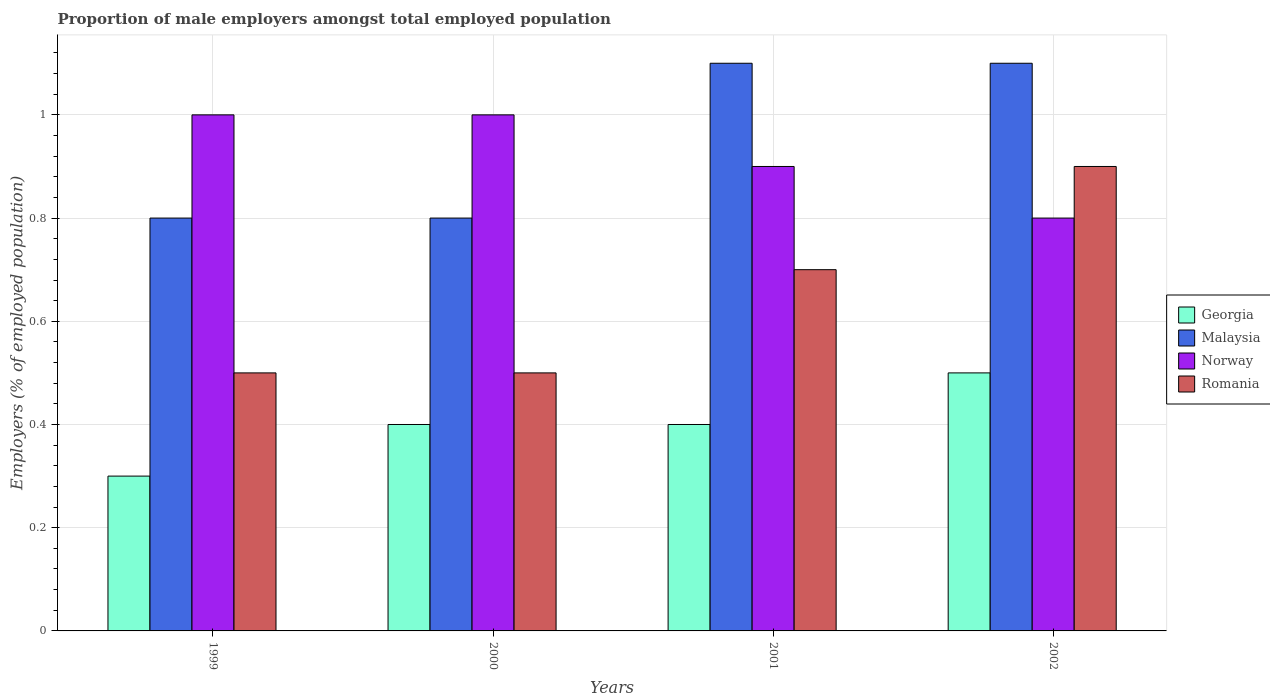How many different coloured bars are there?
Keep it short and to the point. 4. How many groups of bars are there?
Your response must be concise. 4. How many bars are there on the 3rd tick from the left?
Your answer should be very brief. 4. What is the proportion of male employers in Romania in 2001?
Offer a very short reply. 0.7. Across all years, what is the maximum proportion of male employers in Norway?
Offer a terse response. 1. Across all years, what is the minimum proportion of male employers in Malaysia?
Offer a very short reply. 0.8. In which year was the proportion of male employers in Malaysia minimum?
Offer a very short reply. 1999. What is the total proportion of male employers in Malaysia in the graph?
Offer a very short reply. 3.8. What is the difference between the proportion of male employers in Norway in 1999 and that in 2002?
Your answer should be very brief. 0.2. What is the difference between the proportion of male employers in Romania in 2002 and the proportion of male employers in Georgia in 1999?
Your response must be concise. 0.6. What is the average proportion of male employers in Norway per year?
Your answer should be compact. 0.92. In the year 2001, what is the difference between the proportion of male employers in Romania and proportion of male employers in Georgia?
Provide a succinct answer. 0.3. What is the ratio of the proportion of male employers in Georgia in 2000 to that in 2002?
Offer a terse response. 0.8. Is the proportion of male employers in Norway in 2001 less than that in 2002?
Ensure brevity in your answer.  No. What is the difference between the highest and the lowest proportion of male employers in Georgia?
Provide a short and direct response. 0.2. Is the sum of the proportion of male employers in Romania in 1999 and 2001 greater than the maximum proportion of male employers in Georgia across all years?
Your answer should be very brief. Yes. Is it the case that in every year, the sum of the proportion of male employers in Norway and proportion of male employers in Malaysia is greater than the sum of proportion of male employers in Georgia and proportion of male employers in Romania?
Your response must be concise. Yes. What does the 1st bar from the left in 2002 represents?
Offer a terse response. Georgia. What does the 2nd bar from the right in 2001 represents?
Your answer should be very brief. Norway. How many bars are there?
Provide a short and direct response. 16. How many years are there in the graph?
Offer a terse response. 4. What is the difference between two consecutive major ticks on the Y-axis?
Your answer should be very brief. 0.2. Does the graph contain any zero values?
Provide a short and direct response. No. Does the graph contain grids?
Your answer should be compact. Yes. How are the legend labels stacked?
Provide a succinct answer. Vertical. What is the title of the graph?
Give a very brief answer. Proportion of male employers amongst total employed population. What is the label or title of the Y-axis?
Provide a succinct answer. Employers (% of employed population). What is the Employers (% of employed population) in Georgia in 1999?
Your answer should be compact. 0.3. What is the Employers (% of employed population) in Malaysia in 1999?
Provide a short and direct response. 0.8. What is the Employers (% of employed population) in Georgia in 2000?
Offer a terse response. 0.4. What is the Employers (% of employed population) of Malaysia in 2000?
Offer a terse response. 0.8. What is the Employers (% of employed population) in Georgia in 2001?
Provide a short and direct response. 0.4. What is the Employers (% of employed population) of Malaysia in 2001?
Keep it short and to the point. 1.1. What is the Employers (% of employed population) in Norway in 2001?
Your answer should be compact. 0.9. What is the Employers (% of employed population) of Romania in 2001?
Keep it short and to the point. 0.7. What is the Employers (% of employed population) of Georgia in 2002?
Make the answer very short. 0.5. What is the Employers (% of employed population) in Malaysia in 2002?
Provide a short and direct response. 1.1. What is the Employers (% of employed population) in Norway in 2002?
Your answer should be compact. 0.8. What is the Employers (% of employed population) in Romania in 2002?
Offer a very short reply. 0.9. Across all years, what is the maximum Employers (% of employed population) of Georgia?
Provide a succinct answer. 0.5. Across all years, what is the maximum Employers (% of employed population) of Malaysia?
Provide a short and direct response. 1.1. Across all years, what is the maximum Employers (% of employed population) in Romania?
Offer a very short reply. 0.9. Across all years, what is the minimum Employers (% of employed population) of Georgia?
Your answer should be compact. 0.3. Across all years, what is the minimum Employers (% of employed population) in Malaysia?
Keep it short and to the point. 0.8. Across all years, what is the minimum Employers (% of employed population) in Norway?
Your answer should be very brief. 0.8. What is the total Employers (% of employed population) in Georgia in the graph?
Keep it short and to the point. 1.6. What is the total Employers (% of employed population) in Norway in the graph?
Keep it short and to the point. 3.7. What is the total Employers (% of employed population) in Romania in the graph?
Your response must be concise. 2.6. What is the difference between the Employers (% of employed population) in Malaysia in 1999 and that in 2000?
Offer a very short reply. 0. What is the difference between the Employers (% of employed population) of Romania in 1999 and that in 2000?
Make the answer very short. 0. What is the difference between the Employers (% of employed population) in Georgia in 1999 and that in 2001?
Keep it short and to the point. -0.1. What is the difference between the Employers (% of employed population) of Malaysia in 1999 and that in 2001?
Your response must be concise. -0.3. What is the difference between the Employers (% of employed population) in Romania in 1999 and that in 2001?
Give a very brief answer. -0.2. What is the difference between the Employers (% of employed population) of Georgia in 1999 and that in 2002?
Keep it short and to the point. -0.2. What is the difference between the Employers (% of employed population) in Norway in 1999 and that in 2002?
Your answer should be very brief. 0.2. What is the difference between the Employers (% of employed population) in Romania in 2000 and that in 2001?
Your answer should be very brief. -0.2. What is the difference between the Employers (% of employed population) of Malaysia in 2000 and that in 2002?
Provide a succinct answer. -0.3. What is the difference between the Employers (% of employed population) of Norway in 2000 and that in 2002?
Your response must be concise. 0.2. What is the difference between the Employers (% of employed population) in Georgia in 2001 and that in 2002?
Offer a very short reply. -0.1. What is the difference between the Employers (% of employed population) of Norway in 2001 and that in 2002?
Provide a short and direct response. 0.1. What is the difference between the Employers (% of employed population) of Romania in 2001 and that in 2002?
Make the answer very short. -0.2. What is the difference between the Employers (% of employed population) of Georgia in 1999 and the Employers (% of employed population) of Malaysia in 2000?
Give a very brief answer. -0.5. What is the difference between the Employers (% of employed population) in Malaysia in 1999 and the Employers (% of employed population) in Romania in 2000?
Ensure brevity in your answer.  0.3. What is the difference between the Employers (% of employed population) in Norway in 1999 and the Employers (% of employed population) in Romania in 2000?
Provide a succinct answer. 0.5. What is the difference between the Employers (% of employed population) of Georgia in 1999 and the Employers (% of employed population) of Malaysia in 2001?
Offer a terse response. -0.8. What is the difference between the Employers (% of employed population) of Georgia in 1999 and the Employers (% of employed population) of Norway in 2001?
Offer a very short reply. -0.6. What is the difference between the Employers (% of employed population) of Malaysia in 1999 and the Employers (% of employed population) of Norway in 2001?
Your answer should be compact. -0.1. What is the difference between the Employers (% of employed population) in Malaysia in 1999 and the Employers (% of employed population) in Romania in 2001?
Make the answer very short. 0.1. What is the difference between the Employers (% of employed population) in Georgia in 1999 and the Employers (% of employed population) in Romania in 2002?
Offer a terse response. -0.6. What is the difference between the Employers (% of employed population) of Georgia in 2000 and the Employers (% of employed population) of Malaysia in 2001?
Your answer should be compact. -0.7. What is the difference between the Employers (% of employed population) in Georgia in 2000 and the Employers (% of employed population) in Norway in 2001?
Your answer should be compact. -0.5. What is the difference between the Employers (% of employed population) in Georgia in 2000 and the Employers (% of employed population) in Romania in 2001?
Keep it short and to the point. -0.3. What is the difference between the Employers (% of employed population) of Malaysia in 2000 and the Employers (% of employed population) of Norway in 2002?
Provide a succinct answer. 0. What is the difference between the Employers (% of employed population) of Malaysia in 2000 and the Employers (% of employed population) of Romania in 2002?
Keep it short and to the point. -0.1. What is the difference between the Employers (% of employed population) of Georgia in 2001 and the Employers (% of employed population) of Romania in 2002?
Your response must be concise. -0.5. What is the difference between the Employers (% of employed population) in Malaysia in 2001 and the Employers (% of employed population) in Romania in 2002?
Give a very brief answer. 0.2. What is the difference between the Employers (% of employed population) in Norway in 2001 and the Employers (% of employed population) in Romania in 2002?
Provide a succinct answer. 0. What is the average Employers (% of employed population) in Georgia per year?
Offer a very short reply. 0.4. What is the average Employers (% of employed population) of Malaysia per year?
Your response must be concise. 0.95. What is the average Employers (% of employed population) of Norway per year?
Provide a short and direct response. 0.93. What is the average Employers (% of employed population) in Romania per year?
Offer a terse response. 0.65. In the year 1999, what is the difference between the Employers (% of employed population) of Georgia and Employers (% of employed population) of Malaysia?
Offer a very short reply. -0.5. In the year 1999, what is the difference between the Employers (% of employed population) in Georgia and Employers (% of employed population) in Norway?
Offer a very short reply. -0.7. In the year 1999, what is the difference between the Employers (% of employed population) of Malaysia and Employers (% of employed population) of Romania?
Make the answer very short. 0.3. In the year 2000, what is the difference between the Employers (% of employed population) in Georgia and Employers (% of employed population) in Romania?
Keep it short and to the point. -0.1. In the year 2000, what is the difference between the Employers (% of employed population) of Malaysia and Employers (% of employed population) of Norway?
Provide a succinct answer. -0.2. In the year 2000, what is the difference between the Employers (% of employed population) of Malaysia and Employers (% of employed population) of Romania?
Provide a succinct answer. 0.3. In the year 2000, what is the difference between the Employers (% of employed population) in Norway and Employers (% of employed population) in Romania?
Your answer should be very brief. 0.5. In the year 2001, what is the difference between the Employers (% of employed population) of Georgia and Employers (% of employed population) of Malaysia?
Ensure brevity in your answer.  -0.7. In the year 2001, what is the difference between the Employers (% of employed population) of Georgia and Employers (% of employed population) of Norway?
Keep it short and to the point. -0.5. In the year 2001, what is the difference between the Employers (% of employed population) in Malaysia and Employers (% of employed population) in Norway?
Ensure brevity in your answer.  0.2. In the year 2001, what is the difference between the Employers (% of employed population) in Norway and Employers (% of employed population) in Romania?
Keep it short and to the point. 0.2. In the year 2002, what is the difference between the Employers (% of employed population) in Georgia and Employers (% of employed population) in Norway?
Provide a succinct answer. -0.3. In the year 2002, what is the difference between the Employers (% of employed population) of Georgia and Employers (% of employed population) of Romania?
Make the answer very short. -0.4. In the year 2002, what is the difference between the Employers (% of employed population) in Malaysia and Employers (% of employed population) in Romania?
Make the answer very short. 0.2. In the year 2002, what is the difference between the Employers (% of employed population) in Norway and Employers (% of employed population) in Romania?
Give a very brief answer. -0.1. What is the ratio of the Employers (% of employed population) in Norway in 1999 to that in 2000?
Offer a very short reply. 1. What is the ratio of the Employers (% of employed population) in Romania in 1999 to that in 2000?
Your answer should be compact. 1. What is the ratio of the Employers (% of employed population) in Malaysia in 1999 to that in 2001?
Provide a succinct answer. 0.73. What is the ratio of the Employers (% of employed population) in Romania in 1999 to that in 2001?
Make the answer very short. 0.71. What is the ratio of the Employers (% of employed population) in Georgia in 1999 to that in 2002?
Your response must be concise. 0.6. What is the ratio of the Employers (% of employed population) of Malaysia in 1999 to that in 2002?
Make the answer very short. 0.73. What is the ratio of the Employers (% of employed population) in Norway in 1999 to that in 2002?
Your answer should be compact. 1.25. What is the ratio of the Employers (% of employed population) of Romania in 1999 to that in 2002?
Keep it short and to the point. 0.56. What is the ratio of the Employers (% of employed population) of Georgia in 2000 to that in 2001?
Ensure brevity in your answer.  1. What is the ratio of the Employers (% of employed population) in Malaysia in 2000 to that in 2001?
Your answer should be compact. 0.73. What is the ratio of the Employers (% of employed population) in Norway in 2000 to that in 2001?
Provide a short and direct response. 1.11. What is the ratio of the Employers (% of employed population) of Romania in 2000 to that in 2001?
Provide a succinct answer. 0.71. What is the ratio of the Employers (% of employed population) of Malaysia in 2000 to that in 2002?
Ensure brevity in your answer.  0.73. What is the ratio of the Employers (% of employed population) in Romania in 2000 to that in 2002?
Provide a succinct answer. 0.56. What is the ratio of the Employers (% of employed population) in Malaysia in 2001 to that in 2002?
Your answer should be very brief. 1. What is the ratio of the Employers (% of employed population) of Norway in 2001 to that in 2002?
Give a very brief answer. 1.12. What is the difference between the highest and the second highest Employers (% of employed population) of Georgia?
Offer a very short reply. 0.1. What is the difference between the highest and the second highest Employers (% of employed population) of Romania?
Give a very brief answer. 0.2. What is the difference between the highest and the lowest Employers (% of employed population) of Georgia?
Your answer should be very brief. 0.2. What is the difference between the highest and the lowest Employers (% of employed population) of Malaysia?
Keep it short and to the point. 0.3. What is the difference between the highest and the lowest Employers (% of employed population) of Romania?
Provide a short and direct response. 0.4. 